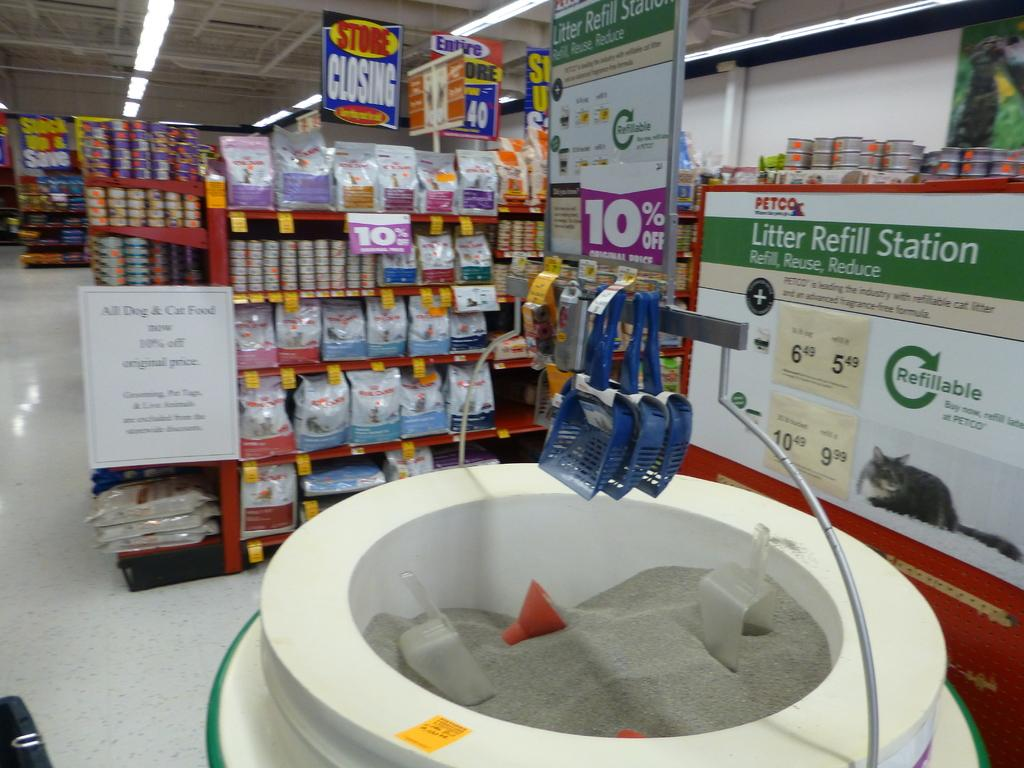<image>
Present a compact description of the photo's key features. The litter refill station at a pet store where customers scoop litter from a large container. 